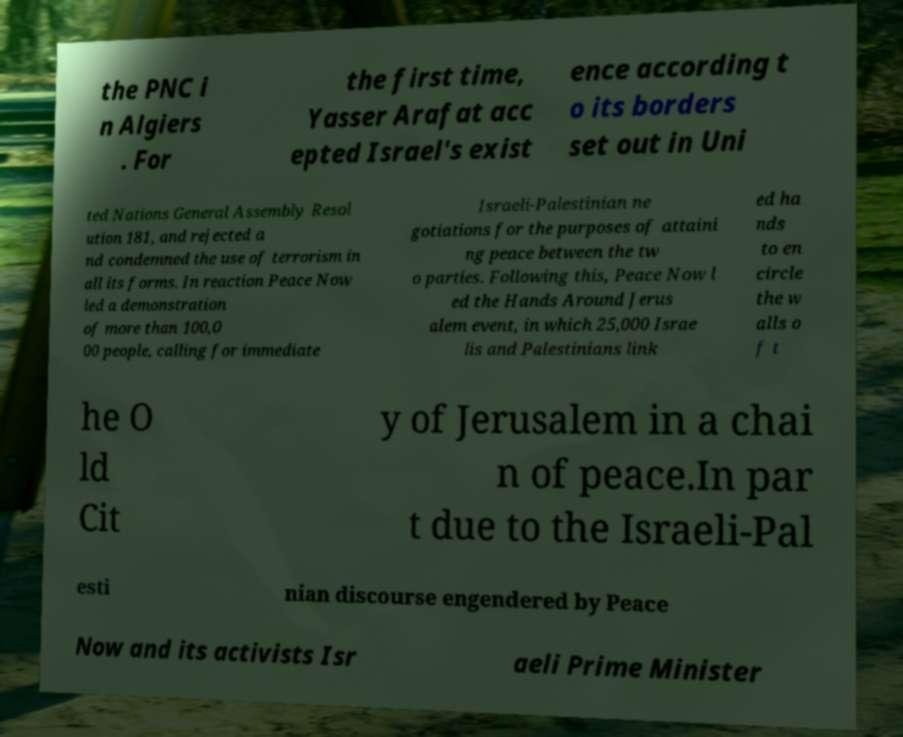For documentation purposes, I need the text within this image transcribed. Could you provide that? the PNC i n Algiers . For the first time, Yasser Arafat acc epted Israel's exist ence according t o its borders set out in Uni ted Nations General Assembly Resol ution 181, and rejected a nd condemned the use of terrorism in all its forms. In reaction Peace Now led a demonstration of more than 100,0 00 people, calling for immediate Israeli-Palestinian ne gotiations for the purposes of attaini ng peace between the tw o parties. Following this, Peace Now l ed the Hands Around Jerus alem event, in which 25,000 Israe lis and Palestinians link ed ha nds to en circle the w alls o f t he O ld Cit y of Jerusalem in a chai n of peace.In par t due to the Israeli-Pal esti nian discourse engendered by Peace Now and its activists Isr aeli Prime Minister 